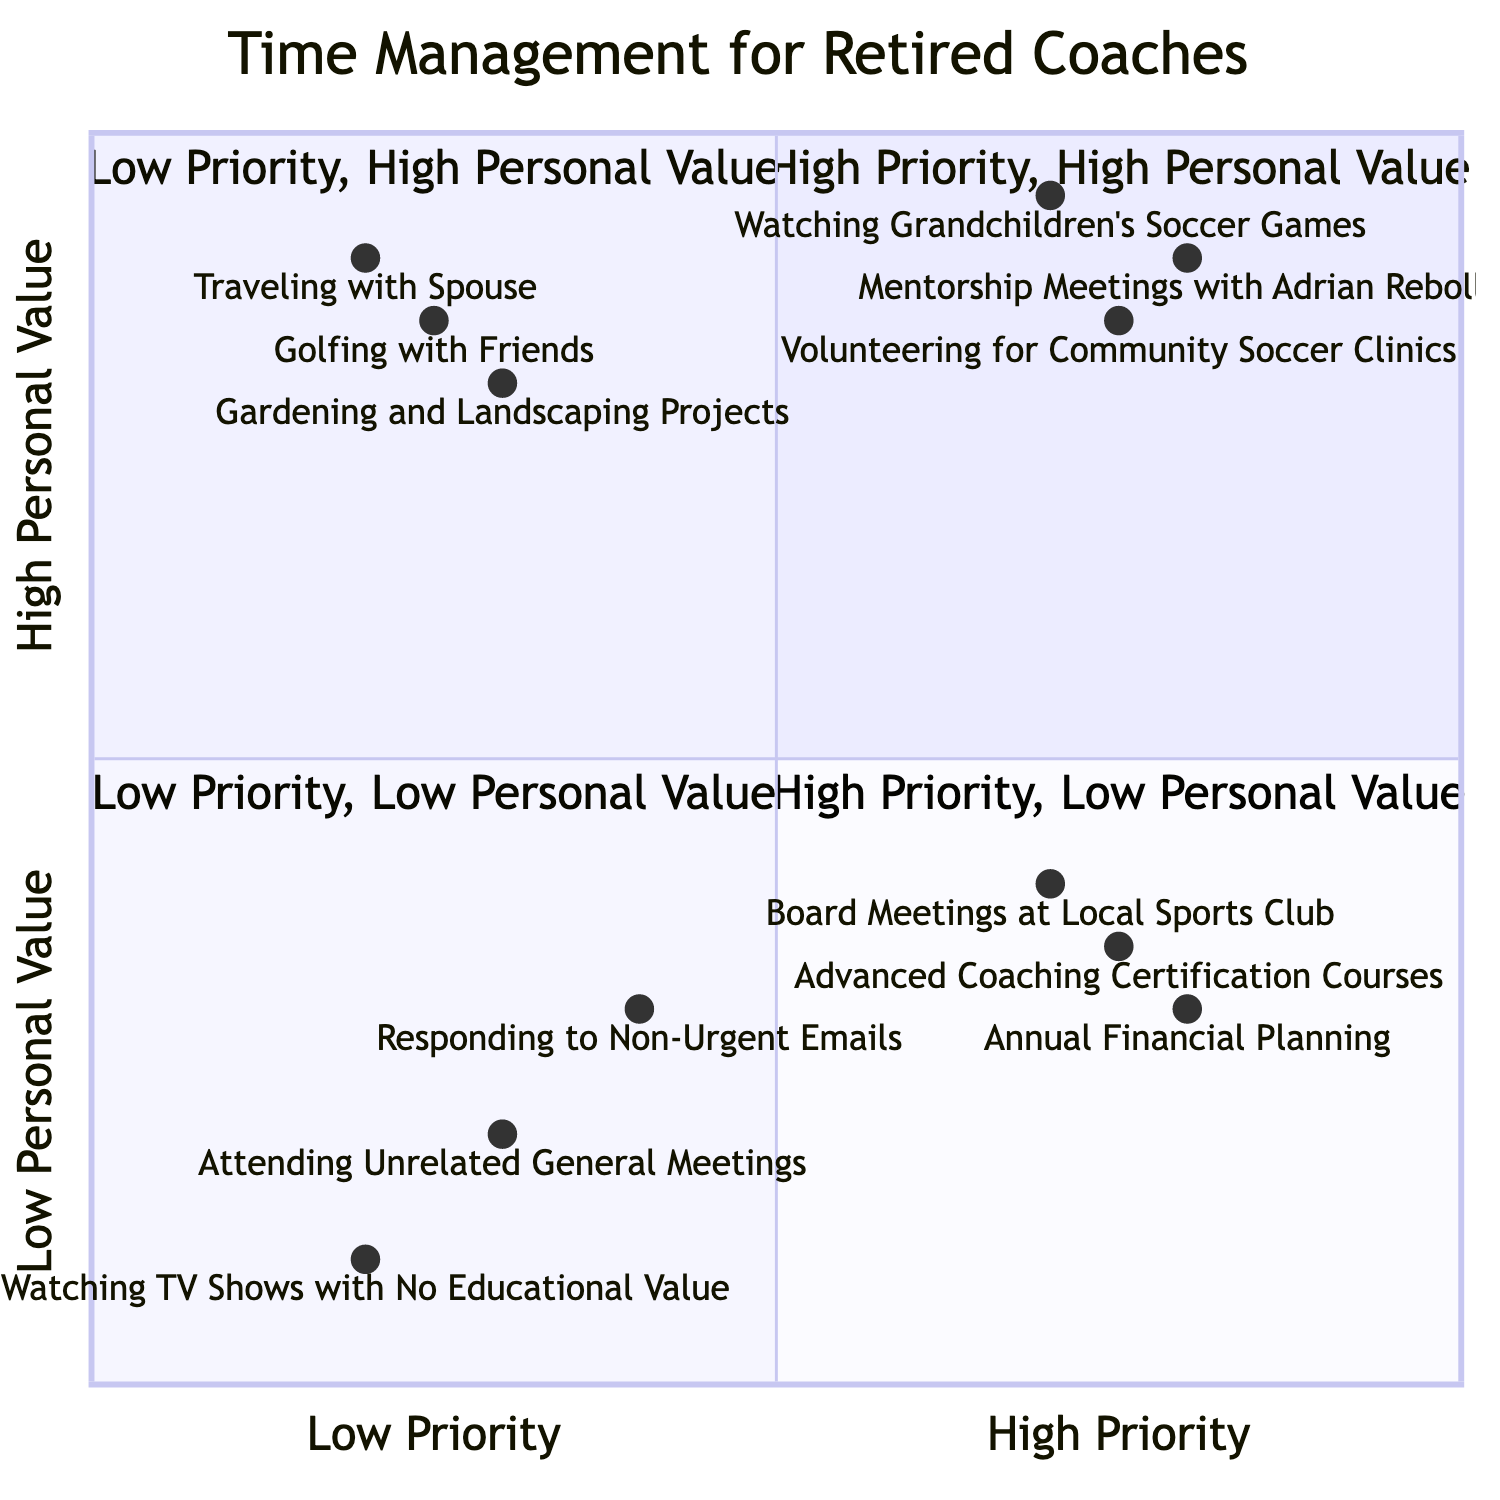What elements are in the "High Priority, High Personal Value" quadrant? The "High Priority, High Personal Value" quadrant includes the elements listed: "Mentorship Meetings with Adrian Rebollar," "Watching Grandchildren's Soccer Games," and "Volunteering for Community Soccer Clinics."
Answer: Mentorship Meetings with Adrian Rebollar, Watching Grandchildren's Soccer Games, Volunteering for Community Soccer Clinics How many elements are in the "Low Priority, Low Personal Value" quadrant? The "Low Priority, Low Personal Value" quadrant consists of three elements: "Attending Unrelated General Meetings," "Responding to Non-Urgent Emails," and "Watching TV Shows with No Educational Value."
Answer: 3 Which activity has the lowest personal value among all listed? Looking at the quadrant "Low Priority, Low Personal Value," the activity with the lowest personal value is "Watching TV Shows with No Educational Value," as it's specifically categorized here.
Answer: Watching TV Shows with No Educational Value Which quadrant contains "Annual Financial Planning"? "Annual Financial Planning" is found in the "High Priority, Low Personal Value" quadrant. The analysis of its placement is based on it being a high priority action that does not provide high personal satisfaction.
Answer: High Priority, Low Personal Value Which two activities provide high personal value but are categorized as low priority? The two activities that provide high personal value but are considered low priority are "Gardening and Landscaping Projects" and "Traveling with Spouse." This is determined by their placement in the "Low Priority, High Personal Value" quadrant while still providing significant personal satisfaction.
Answer: Gardening and Landscaping Projects, Traveling with Spouse What quadrant contains "Golfing with Friends"? "Golfing with Friends" is located in the "Low Priority, High Personal Value" quadrant, showing that, while it may not be urgent, it offers significant enjoyment.
Answer: Low Priority, High Personal Value How does "Volunteering for Community Soccer Clinics" compare in personal value to "Board Meetings at Local Sports Club"? "Volunteering for Community Soccer Clinics" is in the "High Priority, High Personal Value" quadrant, which indicates it is both important and fulfilling. In contrast, "Board Meetings at Local Sports Club" is in the "High Priority, Low Personal Value," meaning it's important but less enjoyable. Therefore, the comparison indicates that the former is more personally valuable.
Answer: Volunteering for Community Soccer Clinics is more valuable Which activity is both high priority and high personal value? The activity that fits both criteria of high priority and high personal value is "Mentorship Meetings with Adrian Rebollar," as it appears in the corresponding quadrant.
Answer: Mentorship Meetings with Adrian Rebollar 